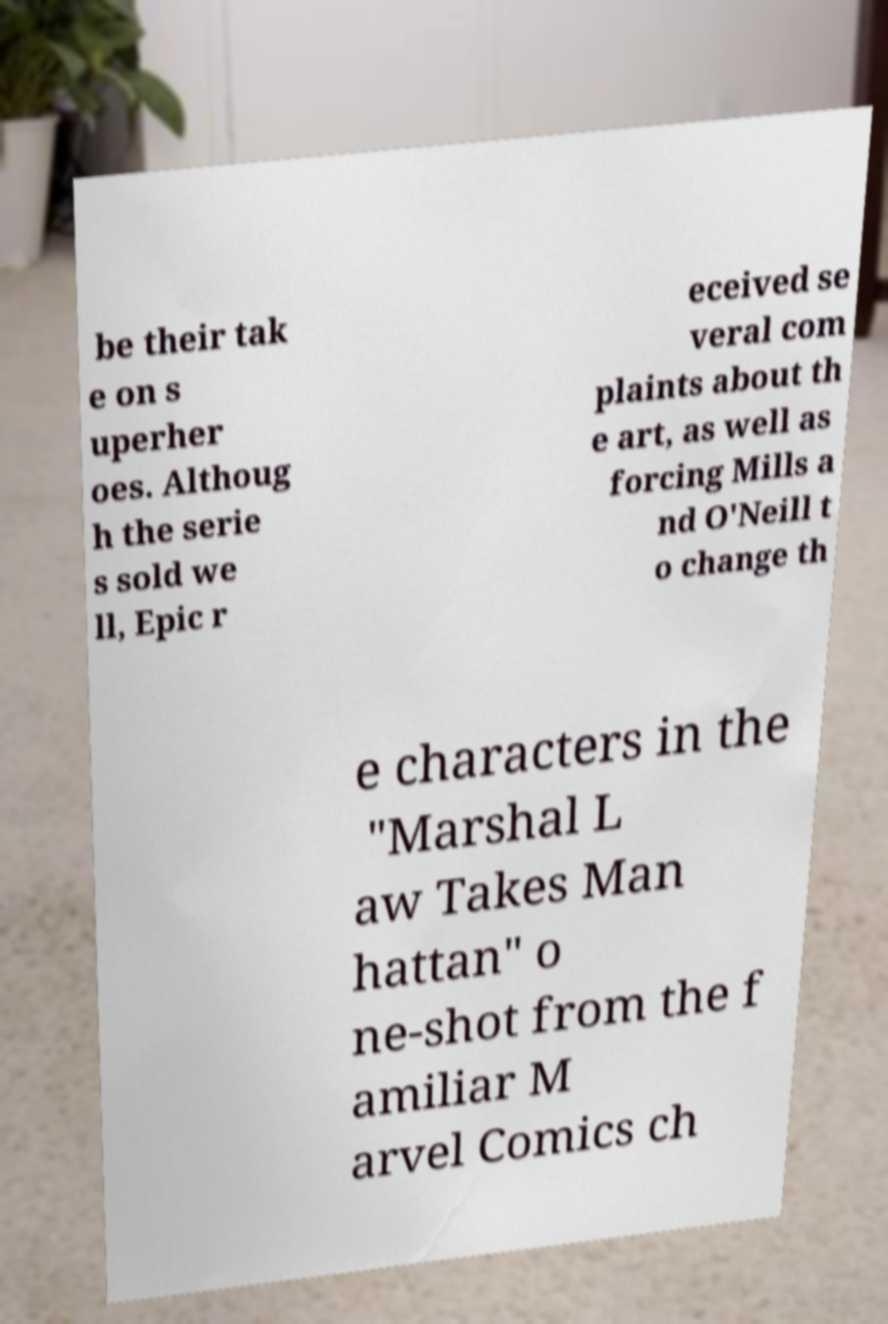Can you accurately transcribe the text from the provided image for me? be their tak e on s uperher oes. Althoug h the serie s sold we ll, Epic r eceived se veral com plaints about th e art, as well as forcing Mills a nd O'Neill t o change th e characters in the "Marshal L aw Takes Man hattan" o ne-shot from the f amiliar M arvel Comics ch 